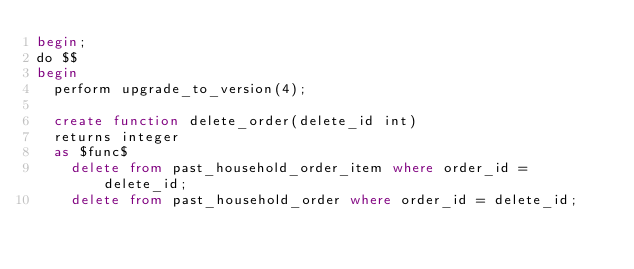<code> <loc_0><loc_0><loc_500><loc_500><_SQL_>begin;
do $$
begin
  perform upgrade_to_version(4);

  create function delete_order(delete_id int) 
  returns integer
  as $func$
    delete from past_household_order_item where order_id = delete_id;
    delete from past_household_order where order_id = delete_id;</code> 